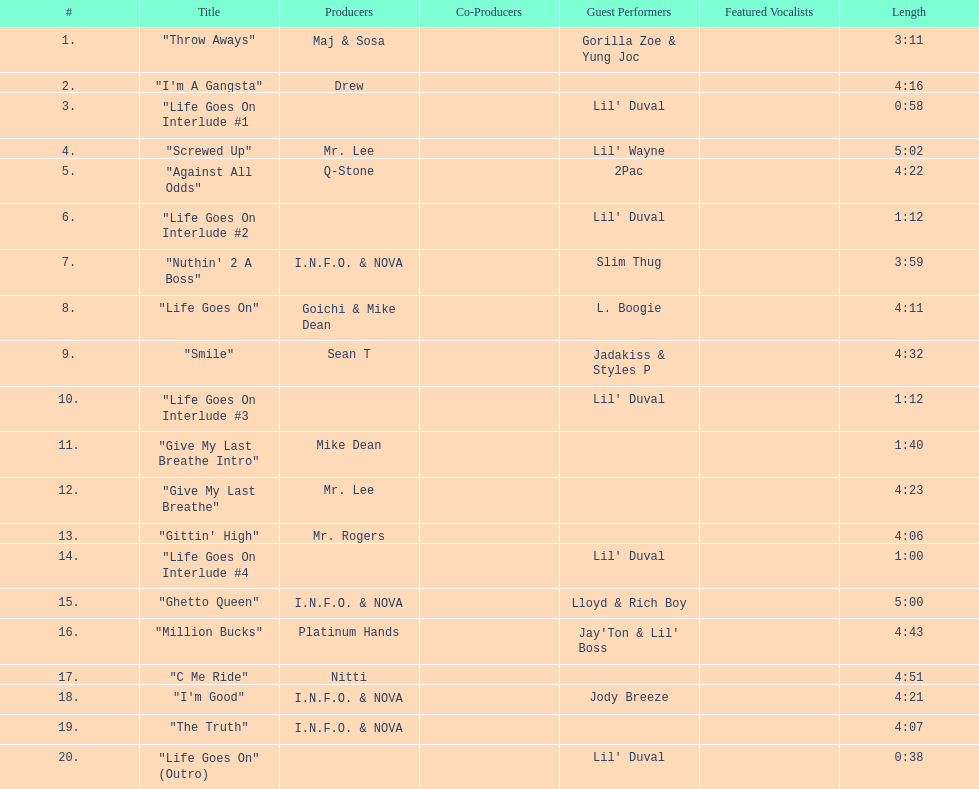Which tracks feature the same producer(s) in consecutive order on this album? "I'm Good", "The Truth". Can you parse all the data within this table? {'header': ['#', 'Title', 'Producers', 'Co-Producers', 'Guest Performers', 'Featured Vocalists', 'Length'], 'rows': [['1.', '"Throw Aways"', 'Maj & Sosa', '', 'Gorilla Zoe & Yung Joc', '', '3:11'], ['2.', '"I\'m A Gangsta"', 'Drew', '', '', '', '4:16'], ['3.', '"Life Goes On Interlude #1', '', '', "Lil' Duval", '', '0:58'], ['4.', '"Screwed Up"', 'Mr. Lee', '', "Lil' Wayne", '', '5:02'], ['5.', '"Against All Odds"', 'Q-Stone', '', '2Pac', '', '4:22'], ['6.', '"Life Goes On Interlude #2', '', '', "Lil' Duval", '', '1:12'], ['7.', '"Nuthin\' 2 A Boss"', 'I.N.F.O. & NOVA', '', 'Slim Thug', '', '3:59'], ['8.', '"Life Goes On"', 'Goichi & Mike Dean', '', 'L. Boogie', '', '4:11'], ['9.', '"Smile"', 'Sean T', '', 'Jadakiss & Styles P', '', '4:32'], ['10.', '"Life Goes On Interlude #3', '', '', "Lil' Duval", '', '1:12'], ['11.', '"Give My Last Breathe Intro"', 'Mike Dean', '', '', '', '1:40'], ['12.', '"Give My Last Breathe"', 'Mr. Lee', '', '', '', '4:23'], ['13.', '"Gittin\' High"', 'Mr. Rogers', '', '', '', '4:06'], ['14.', '"Life Goes On Interlude #4', '', '', "Lil' Duval", '', '1:00'], ['15.', '"Ghetto Queen"', 'I.N.F.O. & NOVA', '', 'Lloyd & Rich Boy', '', '5:00'], ['16.', '"Million Bucks"', 'Platinum Hands', '', "Jay'Ton & Lil' Boss", '', '4:43'], ['17.', '"C Me Ride"', 'Nitti', '', '', '', '4:51'], ['18.', '"I\'m Good"', 'I.N.F.O. & NOVA', '', 'Jody Breeze', '', '4:21'], ['19.', '"The Truth"', 'I.N.F.O. & NOVA', '', '', '', '4:07'], ['20.', '"Life Goes On" (Outro)', '', '', "Lil' Duval", '', '0:38']]} 